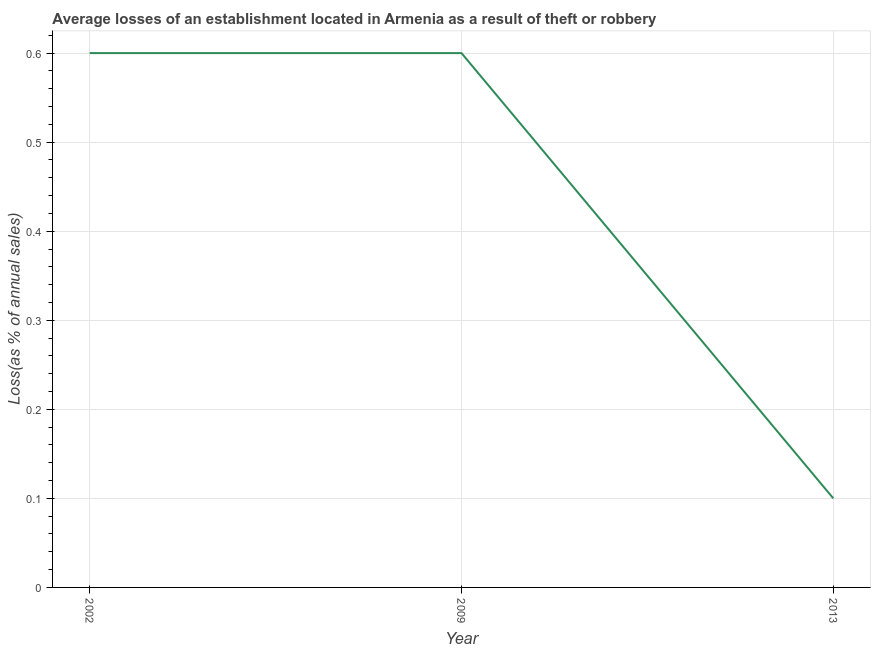What is the losses due to theft in 2002?
Your answer should be compact. 0.6. In which year was the losses due to theft minimum?
Your answer should be compact. 2013. What is the average losses due to theft per year?
Your answer should be very brief. 0.43. In how many years, is the losses due to theft greater than 0.36000000000000004 %?
Your answer should be compact. 2. What is the ratio of the losses due to theft in 2002 to that in 2009?
Give a very brief answer. 1. Is the losses due to theft in 2002 less than that in 2009?
Keep it short and to the point. No. What is the difference between the highest and the lowest losses due to theft?
Your answer should be compact. 0.5. Does the losses due to theft monotonically increase over the years?
Offer a very short reply. No. How many lines are there?
Provide a short and direct response. 1. How many years are there in the graph?
Your response must be concise. 3. Are the values on the major ticks of Y-axis written in scientific E-notation?
Give a very brief answer. No. Does the graph contain grids?
Keep it short and to the point. Yes. What is the title of the graph?
Your response must be concise. Average losses of an establishment located in Armenia as a result of theft or robbery. What is the label or title of the Y-axis?
Make the answer very short. Loss(as % of annual sales). What is the difference between the Loss(as % of annual sales) in 2002 and 2013?
Your answer should be compact. 0.5. What is the difference between the Loss(as % of annual sales) in 2009 and 2013?
Make the answer very short. 0.5. What is the ratio of the Loss(as % of annual sales) in 2002 to that in 2013?
Ensure brevity in your answer.  6. What is the ratio of the Loss(as % of annual sales) in 2009 to that in 2013?
Provide a succinct answer. 6. 